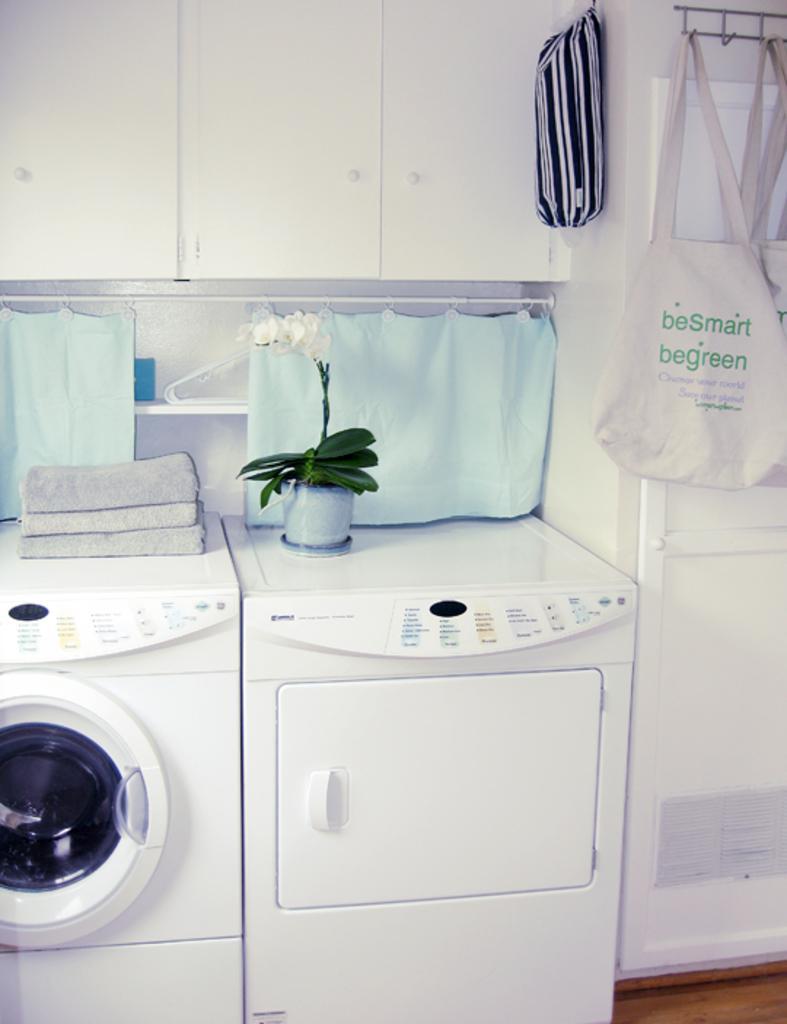How would you summarize this image in a sentence or two? In this image I can see two washing machines. We can see towels and small plant on it. Back I can see blue color curtain. The bags are attached to the wall. The wall is in white color. 